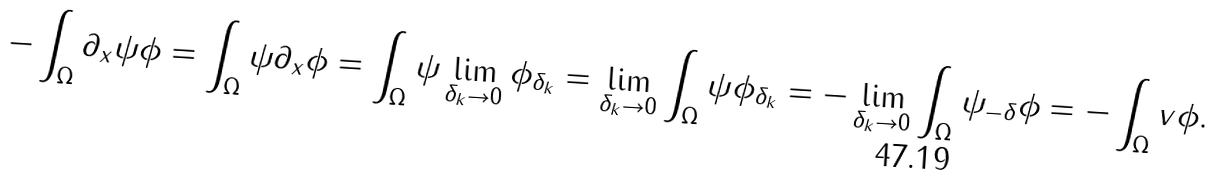Convert formula to latex. <formula><loc_0><loc_0><loc_500><loc_500>- \int _ { \Omega } \partial _ { x } \psi \phi = \int _ { \Omega } \psi \partial _ { x } \phi = \int _ { \Omega } \psi \lim _ { \delta _ { k } \to 0 } \phi _ { \delta _ { k } } = \lim _ { \delta _ { k } \to 0 } \int _ { \Omega } \psi \phi _ { \delta _ { k } } = - \lim _ { \delta _ { k } \to 0 } \int _ { \Omega } \psi _ { - \delta } \phi = - \int _ { \Omega } v \phi .</formula> 